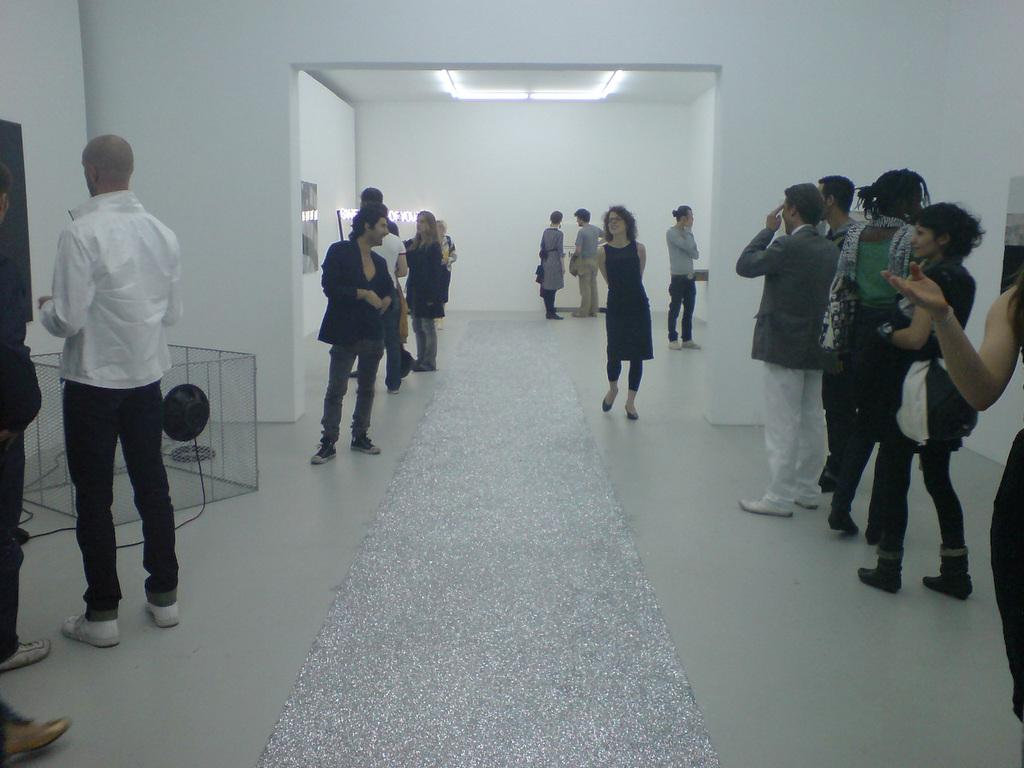How many people are in the group visible in the image? There is a group of people standing in the image, but the exact number cannot be determined from the provided facts. What is on the floor in the image? There is an object on the floor in the image. What can be seen on the wall in the background of the image? There are frames attached to the wall in the background of the image, and there are also lights visible. What type of floor covering is present in the image? There is a carpet in the image. How many tomatoes are being carried by the snail on the edge of the carpet in the image? There is no snail, tomatoes, or edge of the carpet present in the image. 